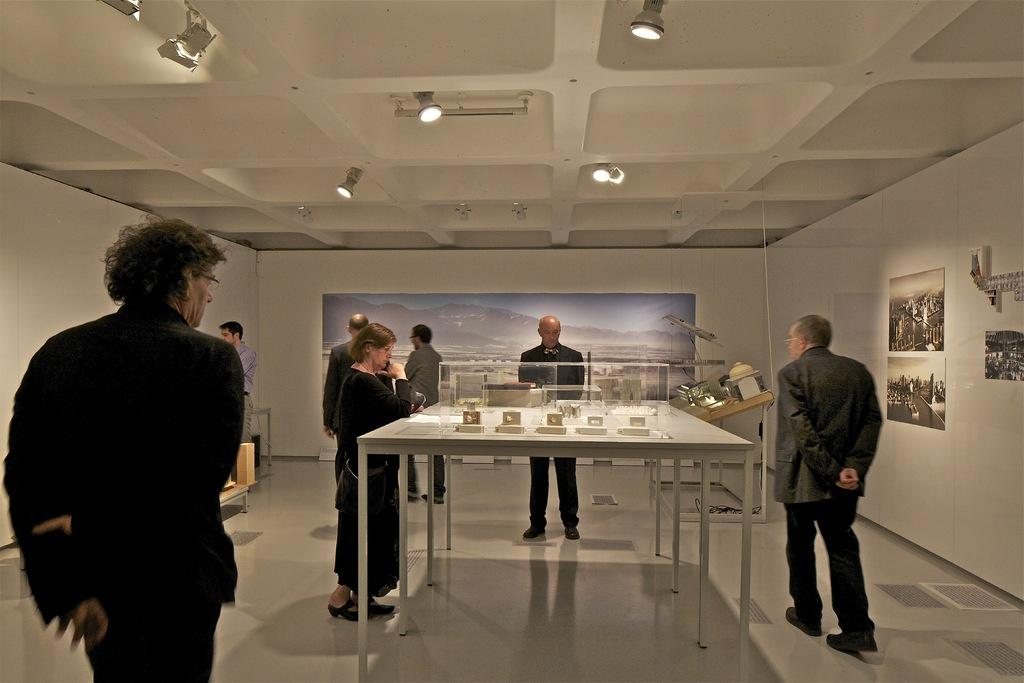What type of place is shown in the image? The location depicted in the image is a museum. What are the people in the image doing? There is a group of people present in the image, and they are visiting the museum. What type of current can be seen flowing through the museum in the image? There is no current visible in the image, as it is a museum and not a body of water. What type of kitty can be seen hiding behind the statue in the image? There is no kitty present in the image; it only shows a group of people visiting the museum. 